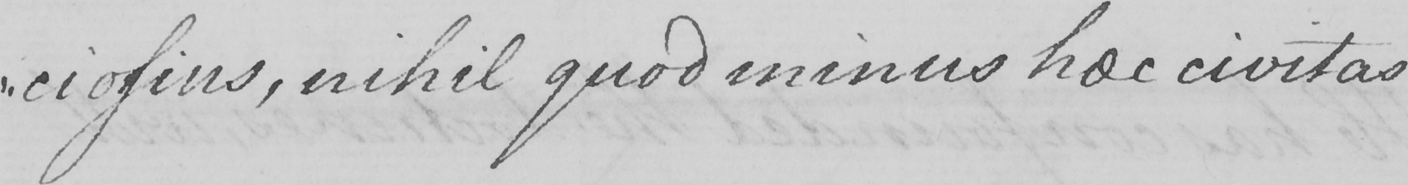Please provide the text content of this handwritten line. -ciosius , nihil quod minus hoc civitas 